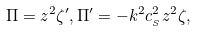Convert formula to latex. <formula><loc_0><loc_0><loc_500><loc_500>\Pi = z ^ { 2 } \zeta ^ { \prime } , \Pi ^ { \prime } = - k ^ { 2 } c _ { _ { S } } ^ { 2 } z ^ { 2 } \zeta ,</formula> 